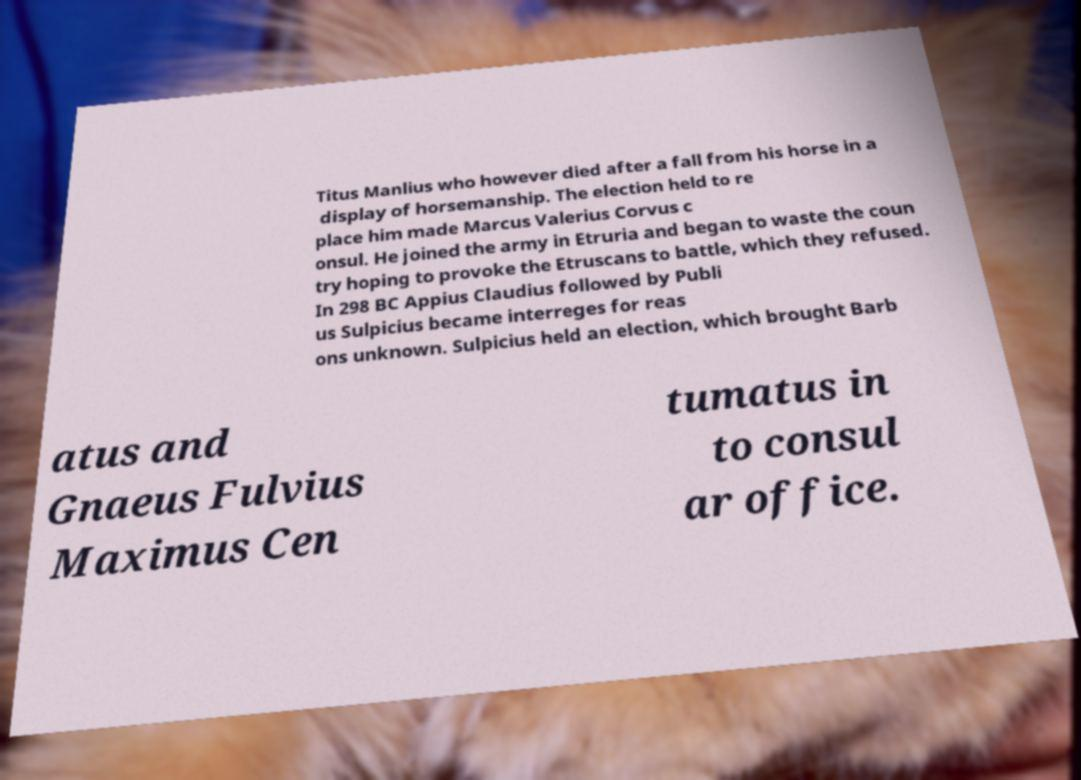I need the written content from this picture converted into text. Can you do that? Titus Manlius who however died after a fall from his horse in a display of horsemanship. The election held to re place him made Marcus Valerius Corvus c onsul. He joined the army in Etruria and began to waste the coun try hoping to provoke the Etruscans to battle, which they refused. In 298 BC Appius Claudius followed by Publi us Sulpicius became interreges for reas ons unknown. Sulpicius held an election, which brought Barb atus and Gnaeus Fulvius Maximus Cen tumatus in to consul ar office. 